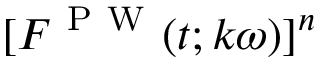Convert formula to latex. <formula><loc_0><loc_0><loc_500><loc_500>[ F ^ { P W } ( t ; k \omega ) ] ^ { n }</formula> 